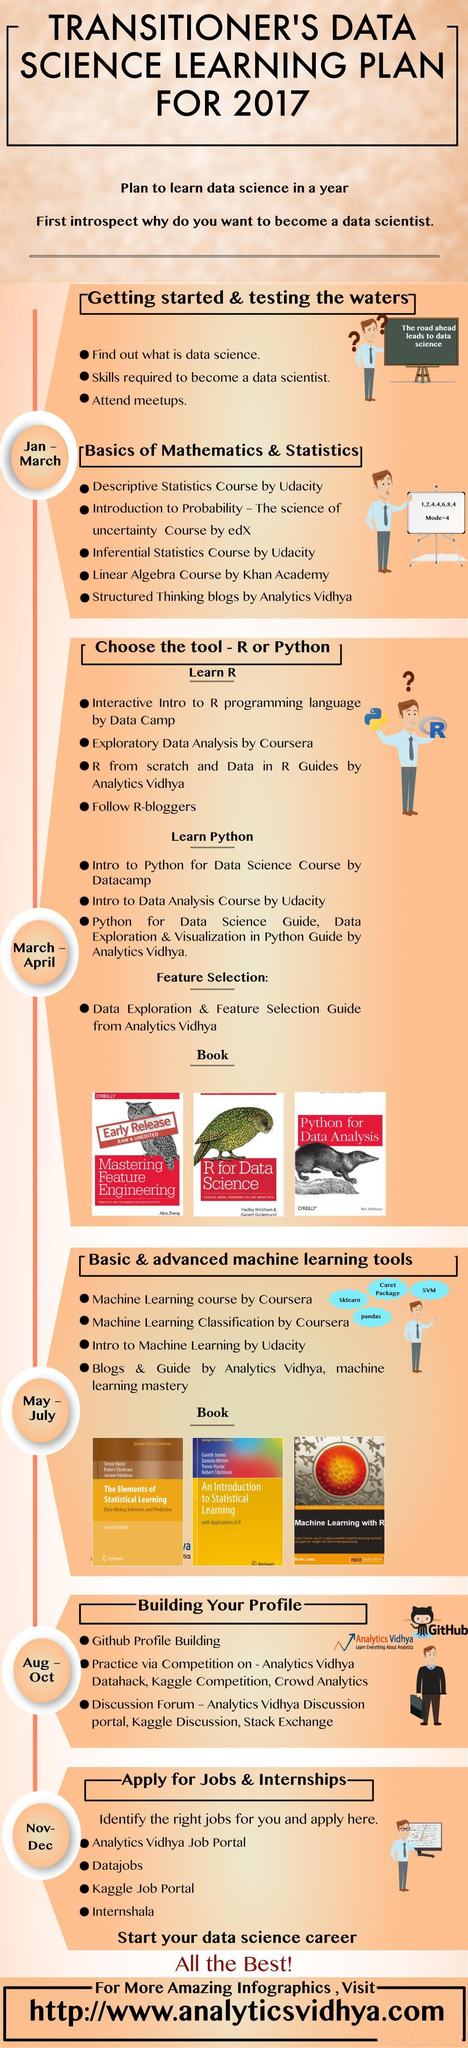How many books related to python are in this infographic?
Answer the question with a short phrase. 3 How many advanced machine learning books are in this infographic? 3 